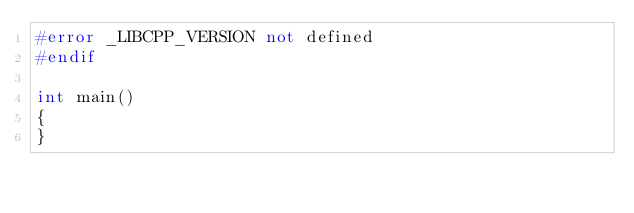<code> <loc_0><loc_0><loc_500><loc_500><_C++_>#error _LIBCPP_VERSION not defined
#endif

int main()
{
}
</code> 